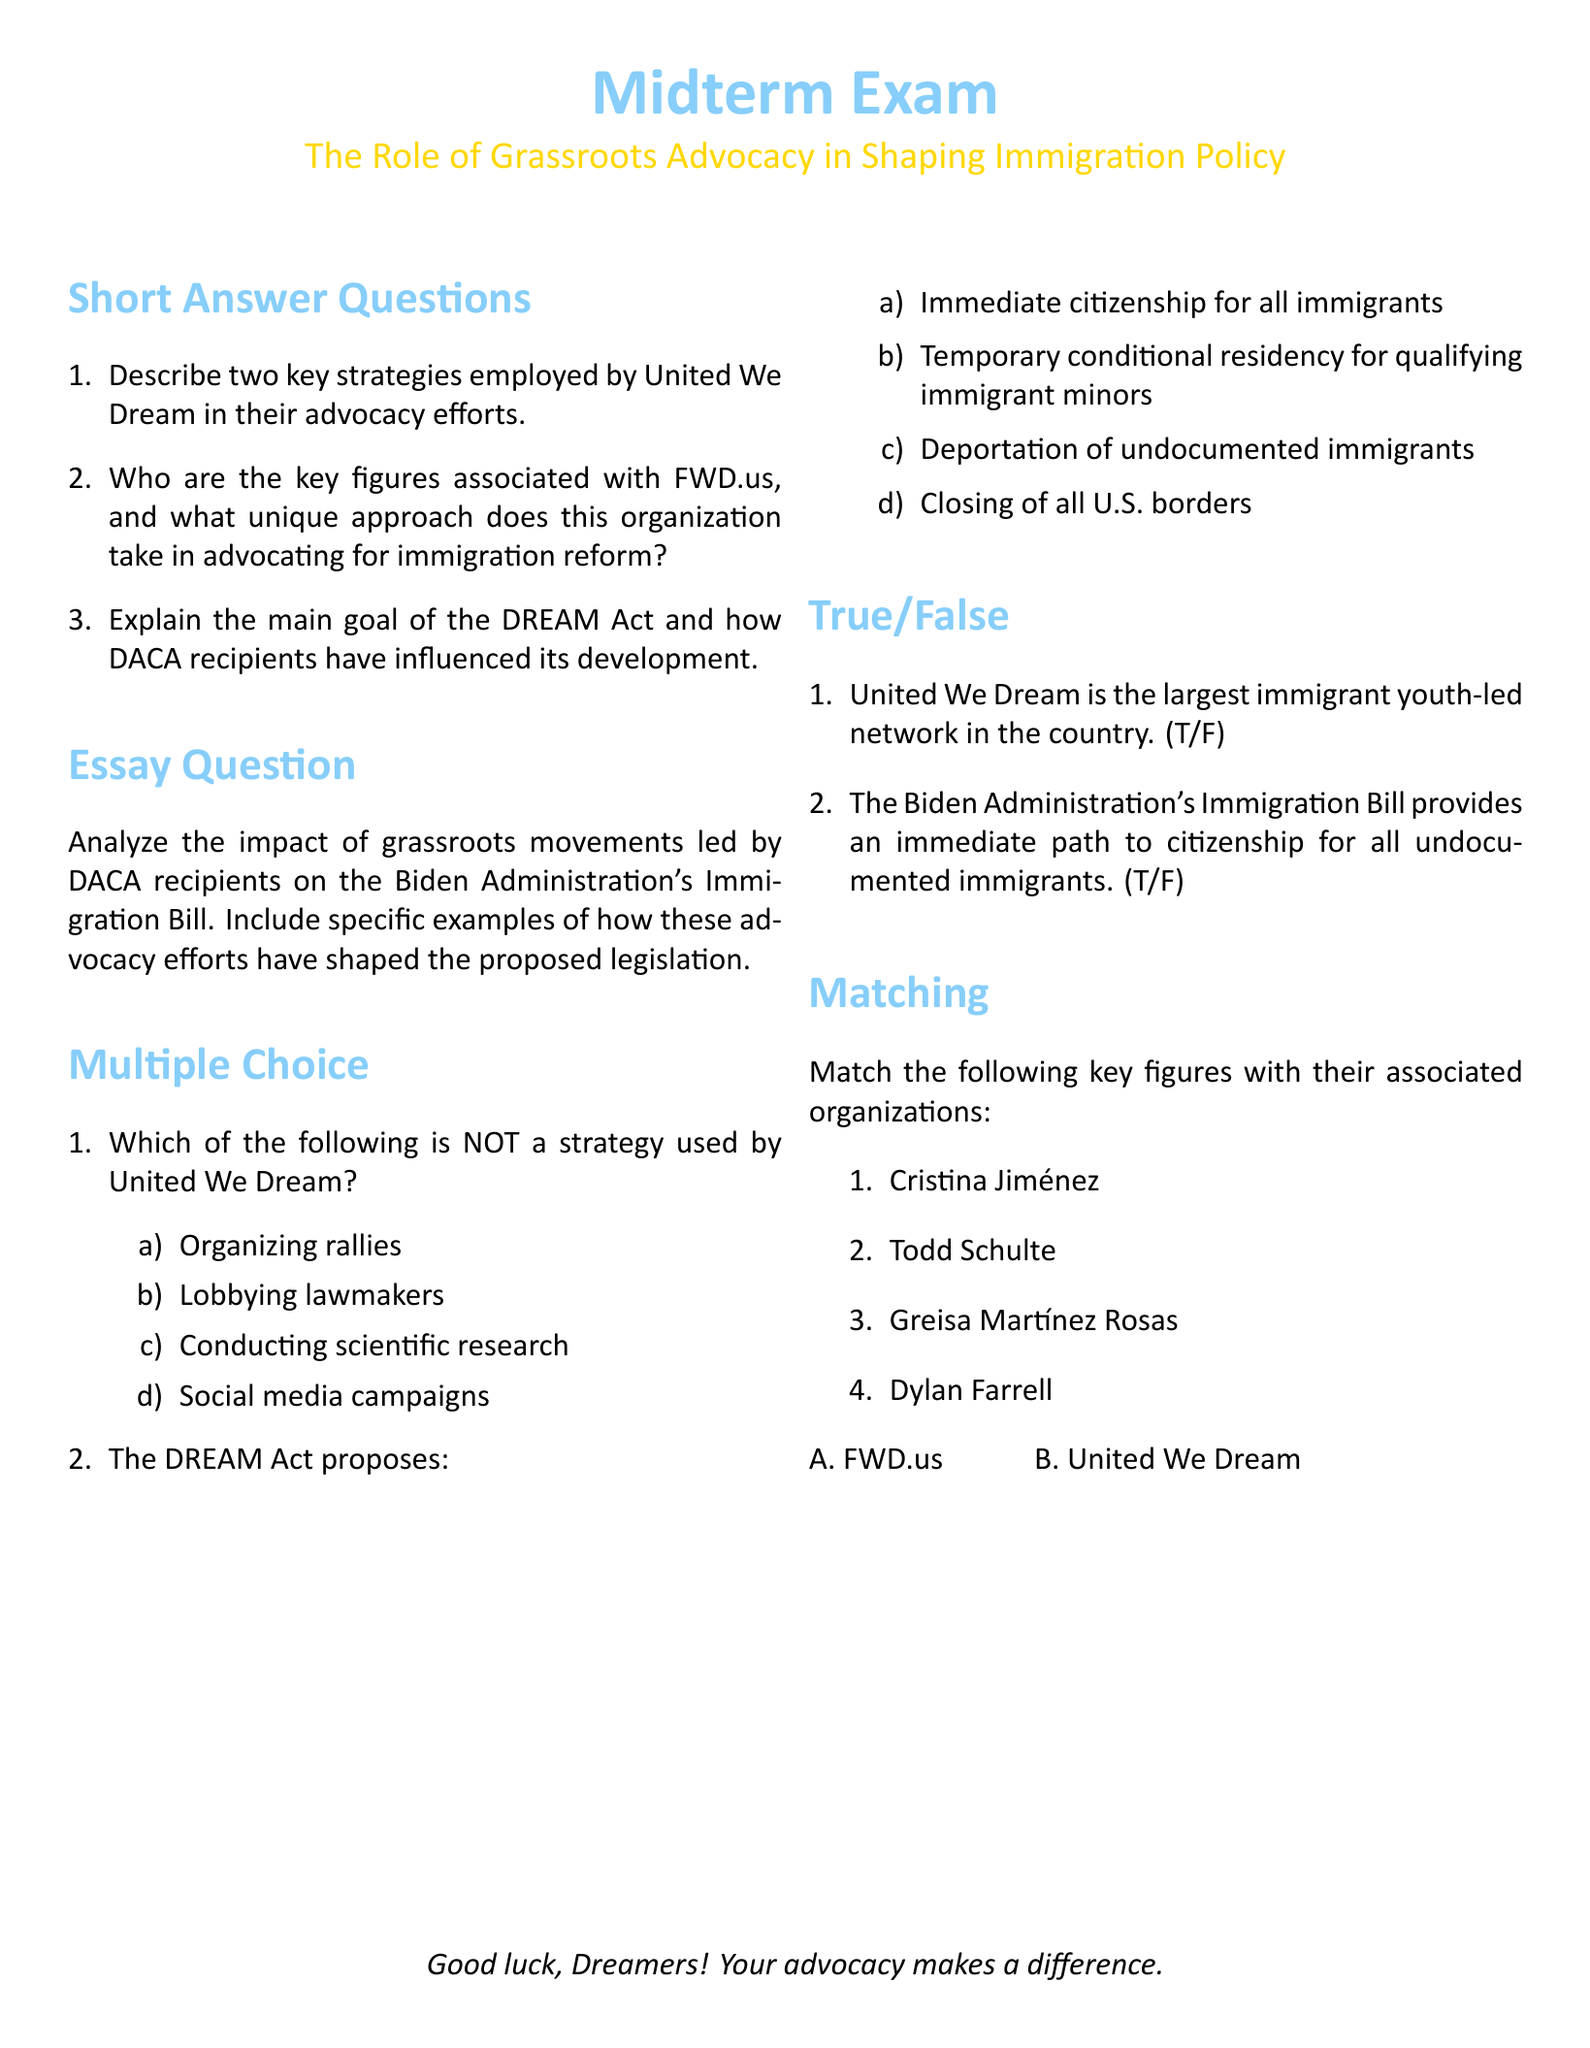What are the two key strategies used by United We Dream? The document lists two strategies as part of the short answer questions section.
Answer: Organizing rallies, Lobbying lawmakers Who is associated with FWD.us? The document specifies Todd Schulte as a key figure in the organization and discusses the organization's unique approach.
Answer: Todd Schulte What is the main goal of the DREAM Act? The main goal of the DREAM Act is highlighted in the short answer questions section of the document.
Answer: Temporary conditional residency for qualifying immigrant minors How many short answer questions are there in the exam? The document provides a total of three short answer questions, detailing the exam's structure.
Answer: 3 What does the True/False question claim about United We Dream? The document states one of the True/False questions inquiring about United We Dream's status as the largest immigrant youth-led network.
Answer: True 